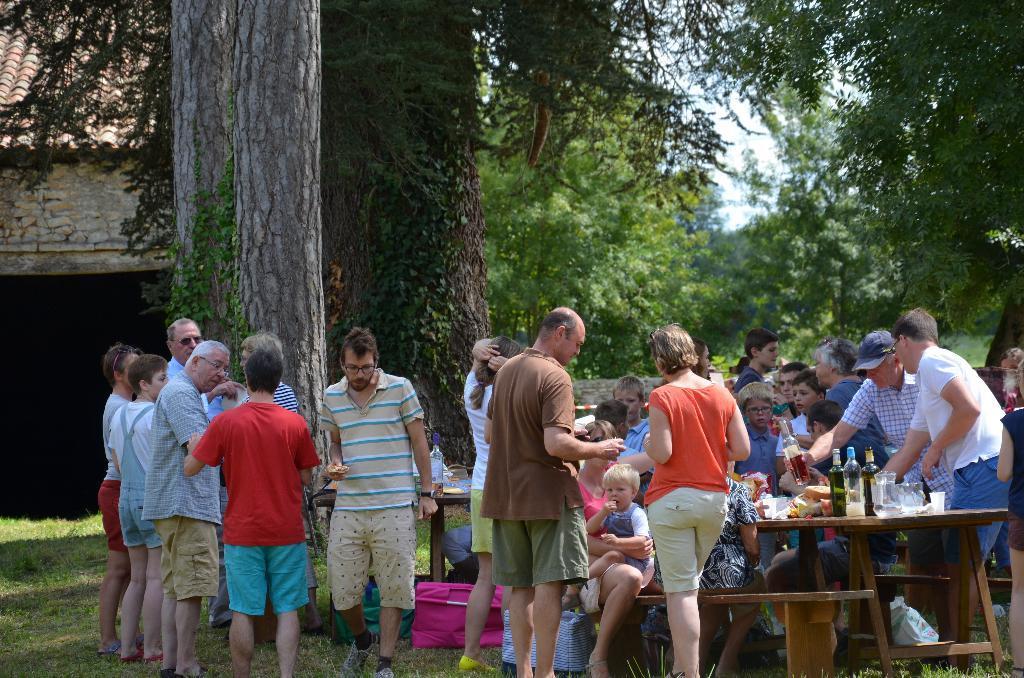Can you describe this image briefly? There are few people standing and few are sitting on the bench at the table. We can see wine bottles,food items on the table. In the background there is a house,trees and sky. 